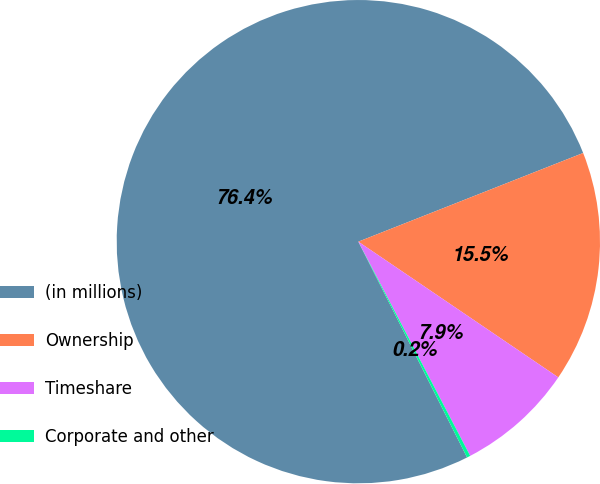<chart> <loc_0><loc_0><loc_500><loc_500><pie_chart><fcel>(in millions)<fcel>Ownership<fcel>Timeshare<fcel>Corporate and other<nl><fcel>76.45%<fcel>15.47%<fcel>7.85%<fcel>0.23%<nl></chart> 